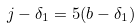<formula> <loc_0><loc_0><loc_500><loc_500>j - \delta _ { 1 } = 5 ( b - \delta _ { 1 } )</formula> 